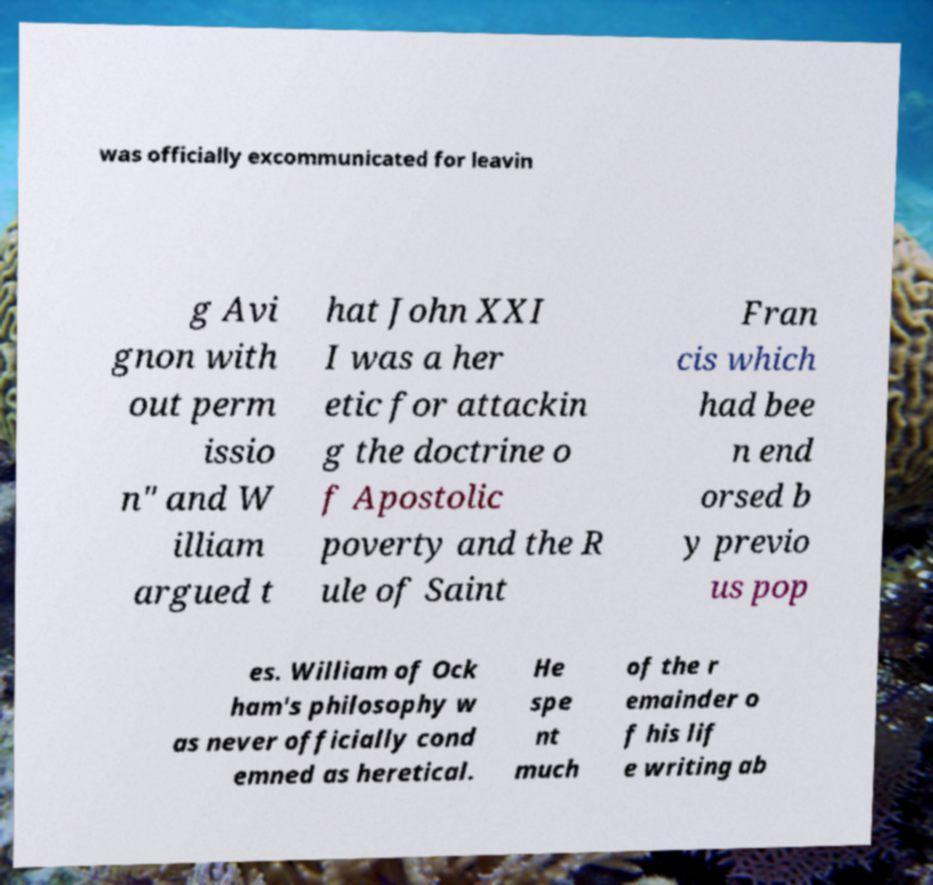Can you accurately transcribe the text from the provided image for me? was officially excommunicated for leavin g Avi gnon with out perm issio n" and W illiam argued t hat John XXI I was a her etic for attackin g the doctrine o f Apostolic poverty and the R ule of Saint Fran cis which had bee n end orsed b y previo us pop es. William of Ock ham's philosophy w as never officially cond emned as heretical. He spe nt much of the r emainder o f his lif e writing ab 